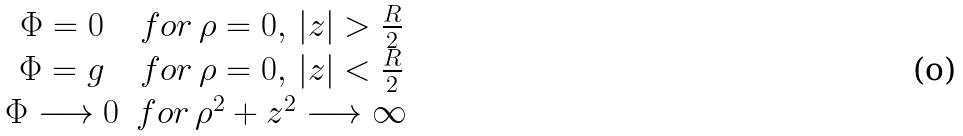<formula> <loc_0><loc_0><loc_500><loc_500>\begin{array} { c c } \Phi = 0 & f o r \, \rho = 0 , \, | z | > \frac { R } { 2 } \\ \Phi = g & f o r \, \rho = 0 , \, | z | < \frac { R } { 2 } \\ \Phi \longrightarrow 0 & f o r \, \rho ^ { 2 } + z ^ { 2 } \longrightarrow \infty \end{array}</formula> 